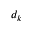Convert formula to latex. <formula><loc_0><loc_0><loc_500><loc_500>d _ { k }</formula> 